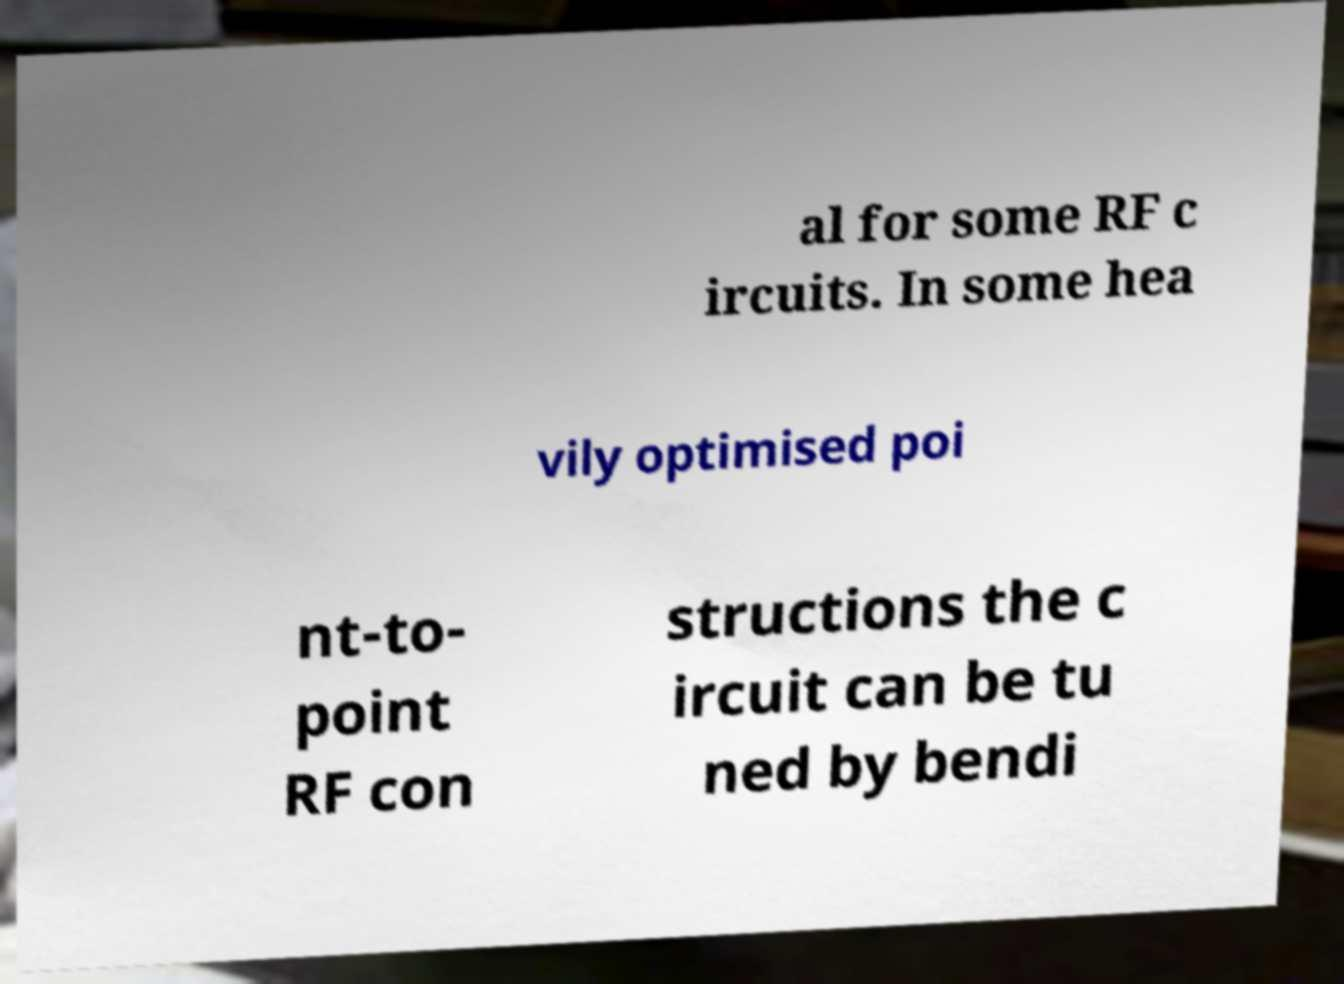For documentation purposes, I need the text within this image transcribed. Could you provide that? al for some RF c ircuits. In some hea vily optimised poi nt-to- point RF con structions the c ircuit can be tu ned by bendi 